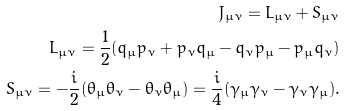<formula> <loc_0><loc_0><loc_500><loc_500>J _ { \mu \nu } = L _ { \mu \nu } + S _ { \mu \nu } \\ L _ { \mu \nu } = \frac { 1 } { 2 } ( q _ { \mu } p _ { \nu } + p _ { \nu } q _ { \mu } - q _ { \nu } p _ { \mu } - p _ { \mu } q _ { \nu } ) \\ S _ { \mu \nu } = - \frac { i } { 2 } ( \theta _ { \mu } \theta _ { \nu } - \theta _ { \nu } \theta _ { \mu } ) = \frac { i } { 4 } ( \gamma _ { \mu } \gamma _ { \nu } - \gamma _ { \nu } \gamma _ { \mu } ) .</formula> 